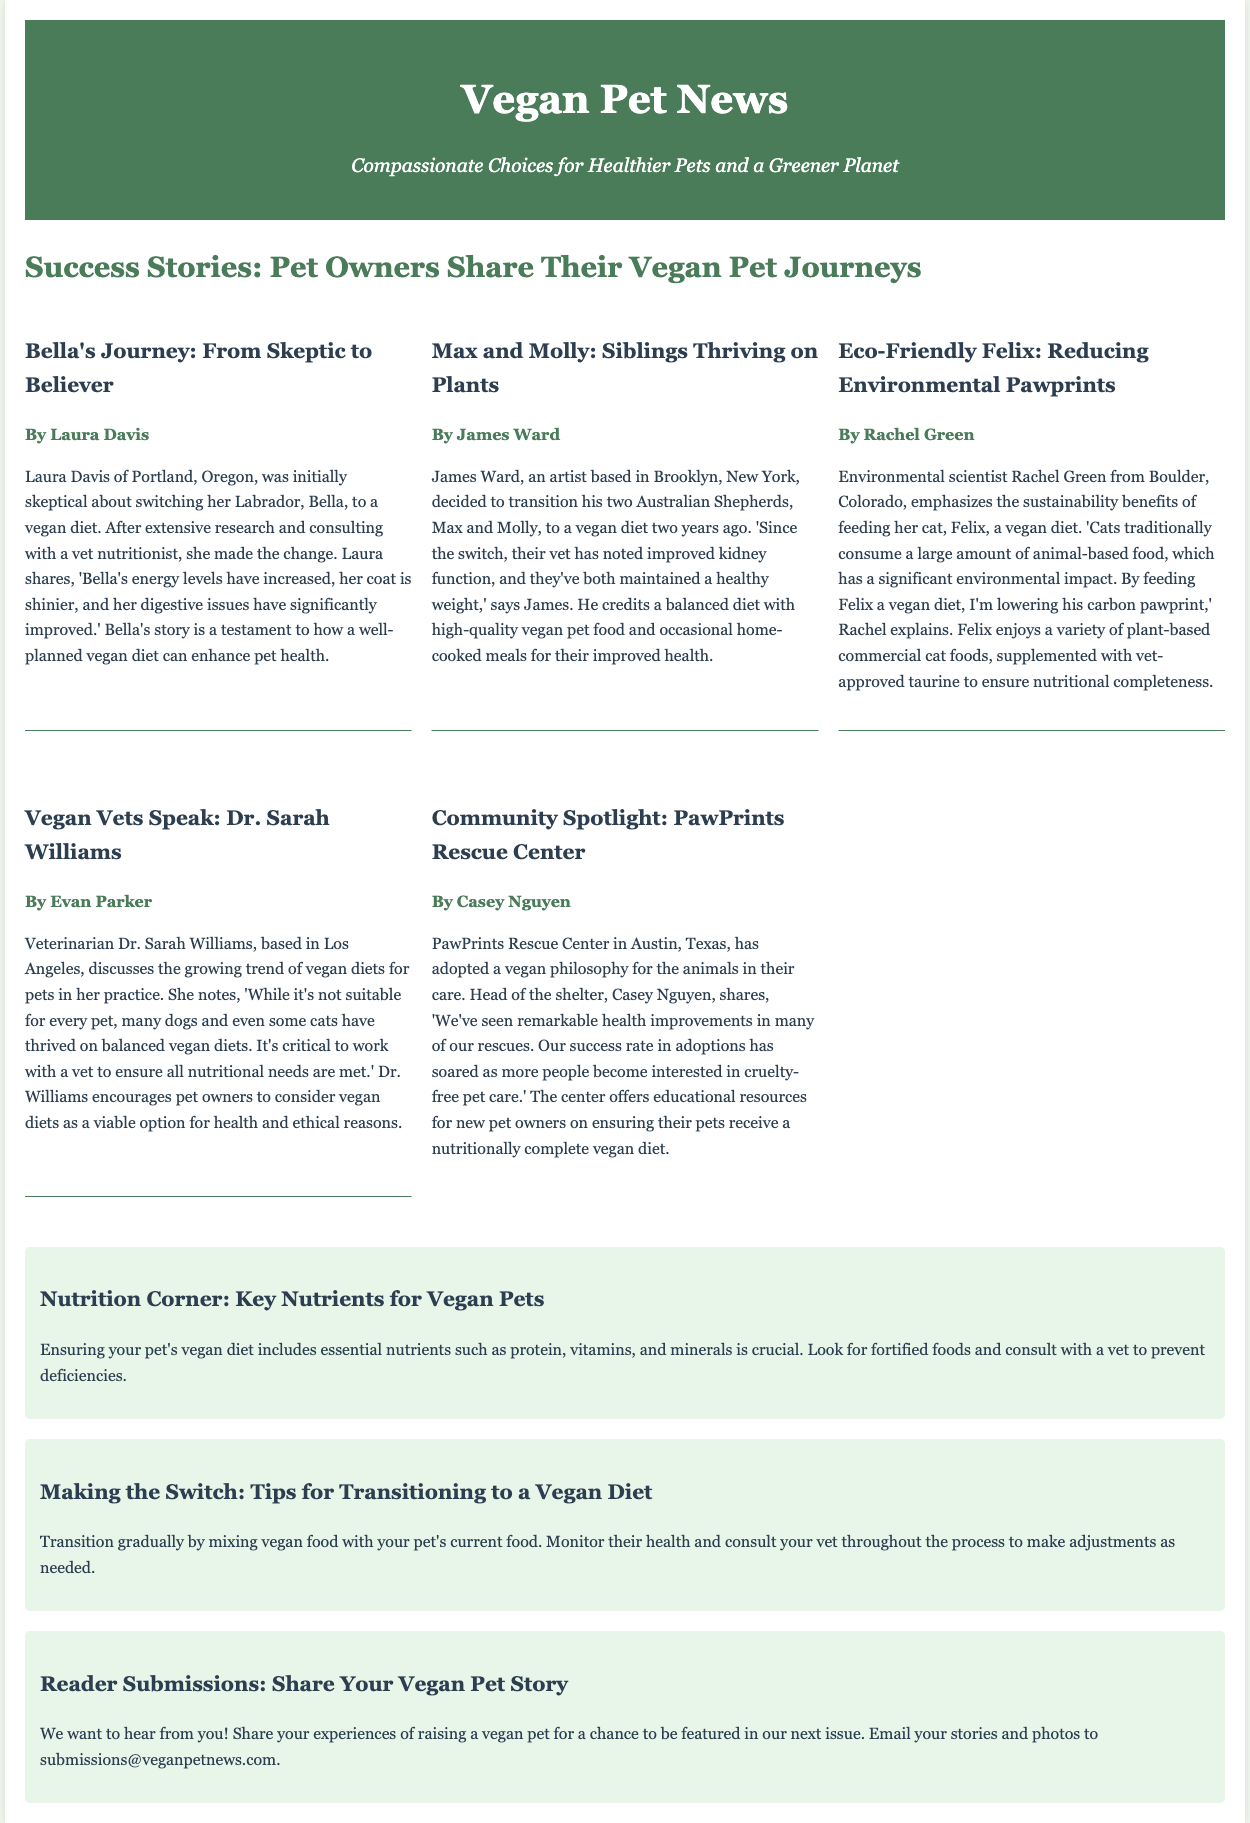what is the title of the article? The title of the article is stated at the top of the main section of the document.
Answer: Success Stories: Pet Owners Share Their Vegan Pet Journeys who is the author of Bella's Journey? The author of Bella's Journey is mentioned below the article title within the document.
Answer: Laura Davis how many pets are featured in the story of Max and Molly? The story of Max and Molly discusses the two siblings, indicating the number of pets featured.
Answer: two what is the profession of Rachel Green? Rachel Green's profession is stated in her introductory sentence within the article.
Answer: Environmental scientist what type of diet does Dr. Sarah Williams discuss? Dr. Sarah Williams discusses a specific type of diet for pets in her section.
Answer: vegan diets what notable improvement did PawPrints Rescue Center observe? The improvement noted by PawPrints Rescue Center relates to the health of the animals in their care.
Answer: health improvements how can pets receive essential nutrients on a vegan diet? Essential nutrients for vegan pets are discussed in the section following the success stories.
Answer: fortified foods what is the email for reader submissions? The document provides an email address for readers to submit their stories.
Answer: submissions@veganpetnews.com 